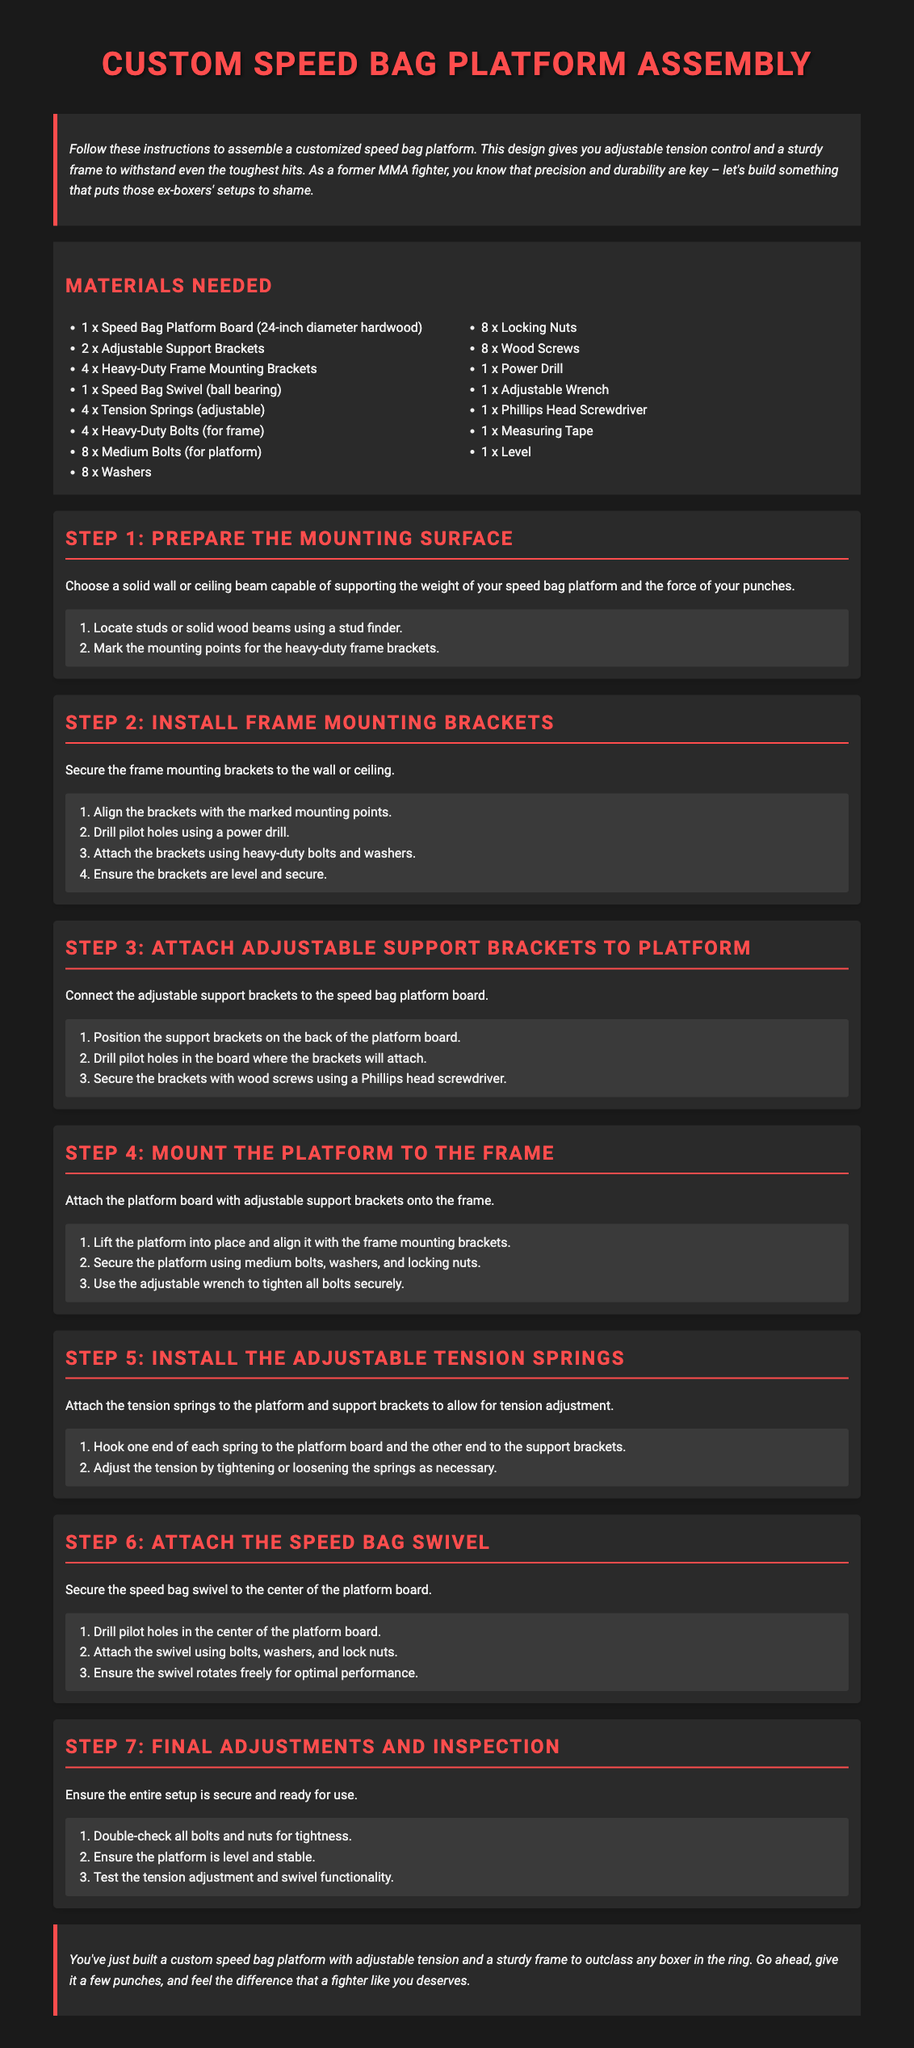What is the diameter of the speed bag platform board? The diameter of the speed bag platform board is mentioned in the materials section as 24 inches.
Answer: 24-inch How many adjustable support brackets are required? The materials section lists that 2 adjustable support brackets are needed.
Answer: 2 What tool is needed to find studs or solid beams? The document mentions using a stud finder for locating studs or solid wood beams.
Answer: Stud finder What is the purpose of the tension springs? The tension springs allow for tension adjustment in the speed bag platform, as described in Step 5.
Answer: Tension adjustment How many heavy-duty bolts are needed for the frame? The materials section specifies that 4 heavy-duty bolts are required for the frame.
Answer: 4 What should you do in Step 7? Step 7 emphasizes the importance of double-checking all bolts and ensuring the platform is level and stable.
Answer: Final adjustments What is installed in Step 6? Step 6 focuses on attaching the speed bag swivel to the center of the platform board.
Answer: Speed bag swivel How many wood screws are needed for the platform? The materials list indicates that 8 wood screws are necessary for the platform.
Answer: 8 What does the introduction emphasize about the assembly? The introduction mentions building something that puts the ex-boxers' setups to shame, highlighting the importance of precision and durability.
Answer: Precision and durability 